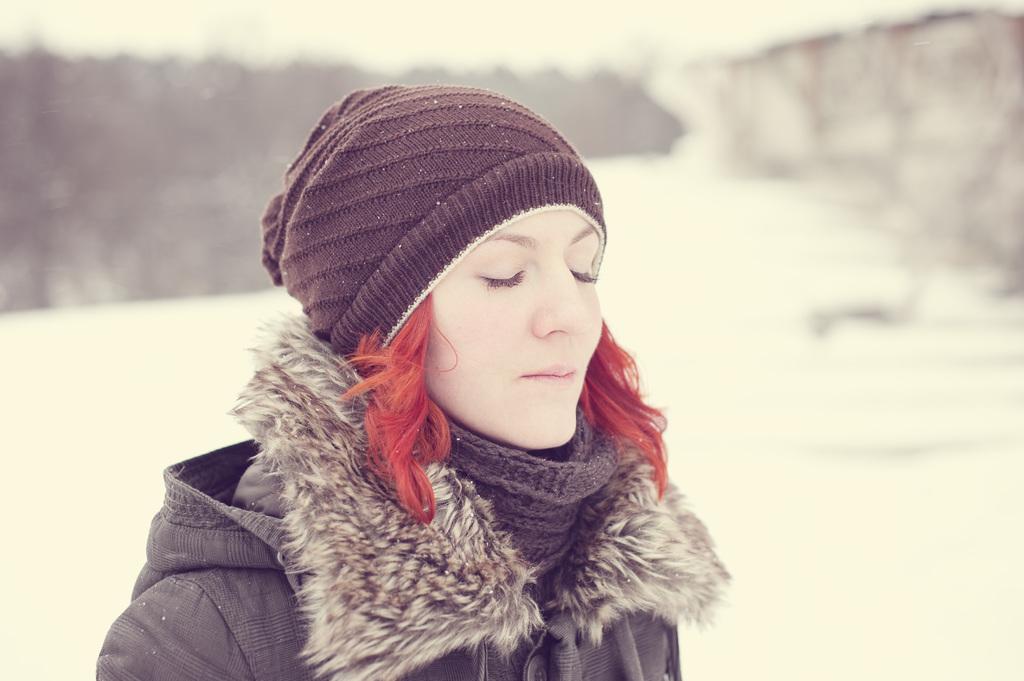Can you describe this image briefly? This picture is clicked outside the city. In the foreground there is a woman wearing a jacket and closing her eyes and seems to be standing on the ground. In the background we can see there is a lot of snow. 